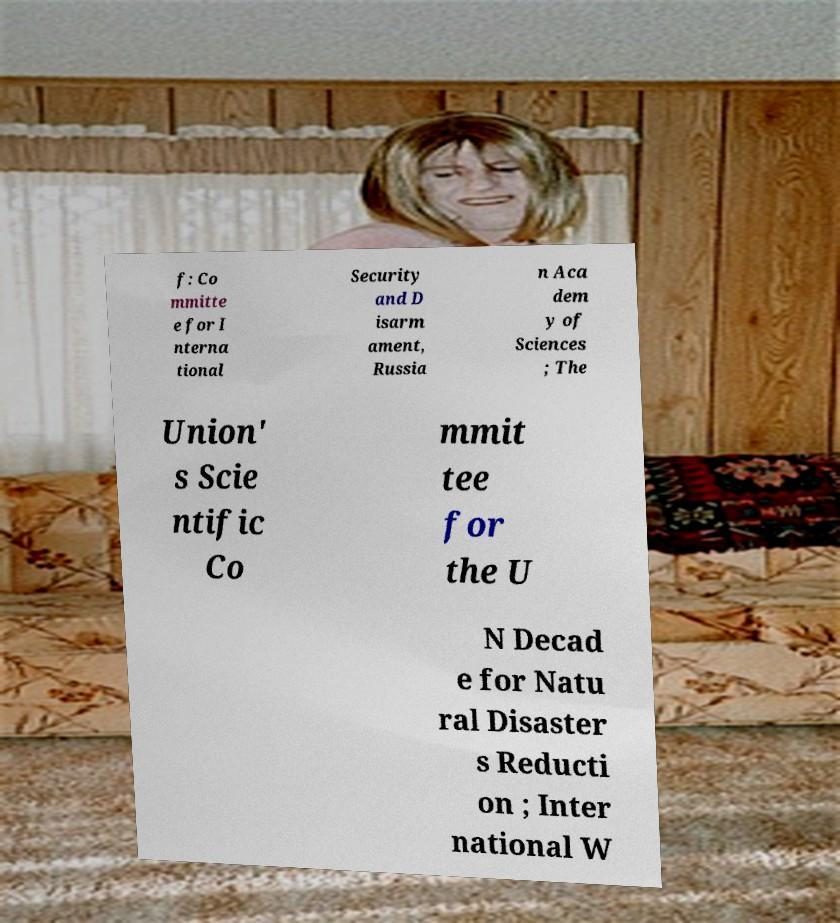Could you extract and type out the text from this image? f: Co mmitte e for I nterna tional Security and D isarm ament, Russia n Aca dem y of Sciences ; The Union' s Scie ntific Co mmit tee for the U N Decad e for Natu ral Disaster s Reducti on ; Inter national W 